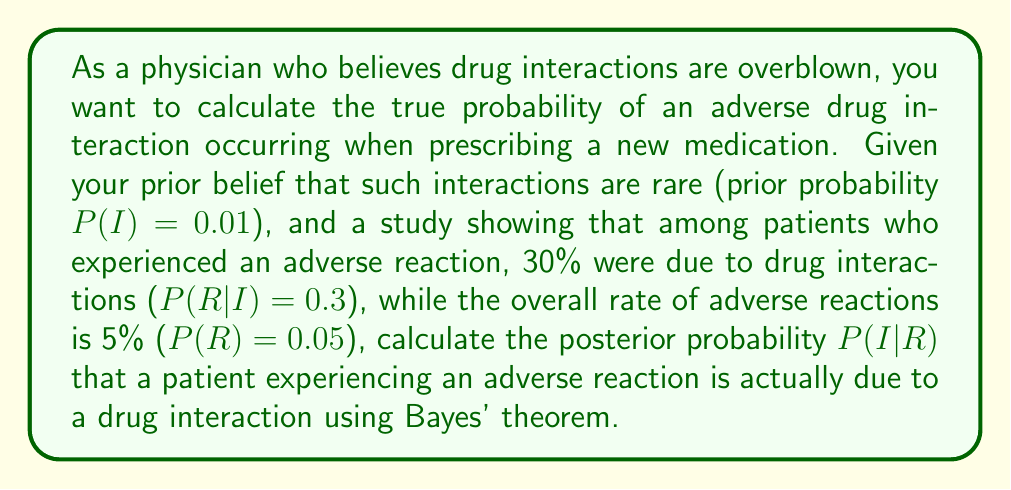What is the answer to this math problem? To solve this problem, we'll use Bayes' theorem, which is given by:

$$P(I|R) = \frac{P(R|I) \cdot P(I)}{P(R)}$$

Where:
$P(I|R)$ is the posterior probability of a drug interaction given an adverse reaction
$P(R|I)$ is the likelihood of an adverse reaction given a drug interaction
$P(I)$ is the prior probability of a drug interaction
$P(R)$ is the marginal likelihood of an adverse reaction

We're given:
$P(I) = 0.01$ (prior probability of drug interaction)
$P(R|I) = 0.3$ (likelihood of adverse reaction given drug interaction)
$P(R) = 0.05$ (marginal likelihood of adverse reaction)

Now, let's substitute these values into Bayes' theorem:

$$P(I|R) = \frac{0.3 \cdot 0.01}{0.05}$$

$$P(I|R) = \frac{0.003}{0.05}$$

$$P(I|R) = 0.06$$
Answer: $P(I|R) = 0.06$ or 6% 